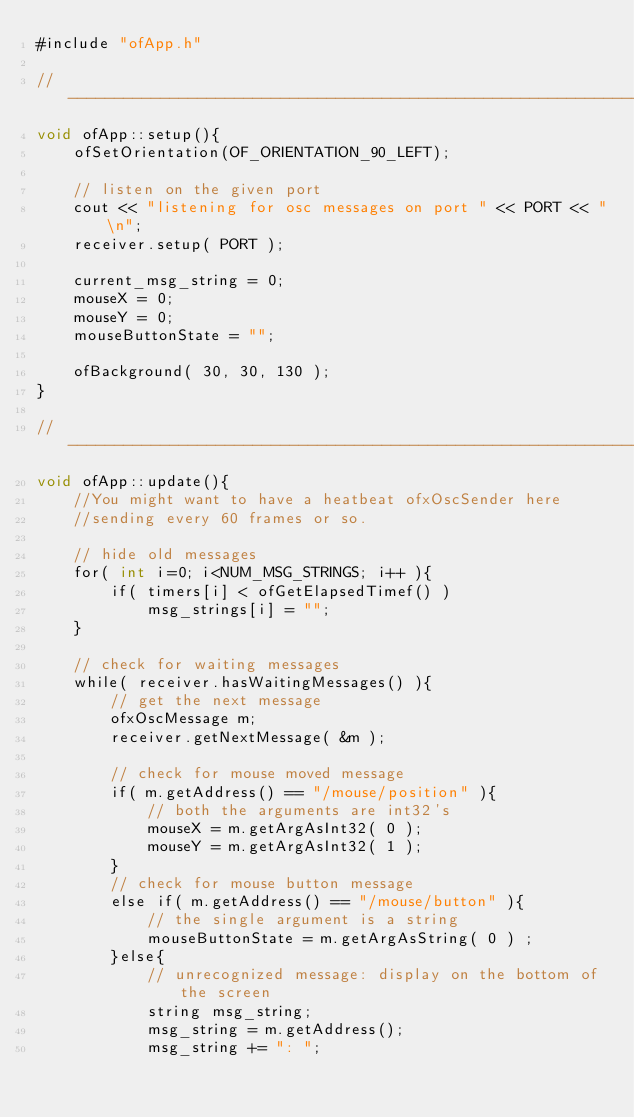Convert code to text. <code><loc_0><loc_0><loc_500><loc_500><_ObjectiveC_>#include "ofApp.h"

//--------------------------------------------------------------
void ofApp::setup(){
	ofSetOrientation(OF_ORIENTATION_90_LEFT);

	// listen on the given port
	cout << "listening for osc messages on port " << PORT << "\n";
	receiver.setup( PORT );

	current_msg_string = 0;
	mouseX = 0;
	mouseY = 0;
	mouseButtonState = "";

	ofBackground( 30, 30, 130 );
}

//--------------------------------------------------------------
void ofApp::update(){
	//You might want to have a heatbeat ofxOscSender here
	//sending every 60 frames or so.
	
	// hide old messages
	for( int i=0; i<NUM_MSG_STRINGS; i++ ){
		if( timers[i] < ofGetElapsedTimef() )
			msg_strings[i] = "";
	}

	// check for waiting messages
	while( receiver.hasWaitingMessages() ){
		// get the next message
		ofxOscMessage m;
		receiver.getNextMessage( &m );

		// check for mouse moved message
		if( m.getAddress() == "/mouse/position" ){
			// both the arguments are int32's
			mouseX = m.getArgAsInt32( 0 );
			mouseY = m.getArgAsInt32( 1 );
		}
		// check for mouse button message
		else if( m.getAddress() == "/mouse/button" ){
			// the single argument is a string
			mouseButtonState = m.getArgAsString( 0 ) ;
		}else{
			// unrecognized message: display on the bottom of the screen
			string msg_string;
			msg_string = m.getAddress();
			msg_string += ": ";</code> 